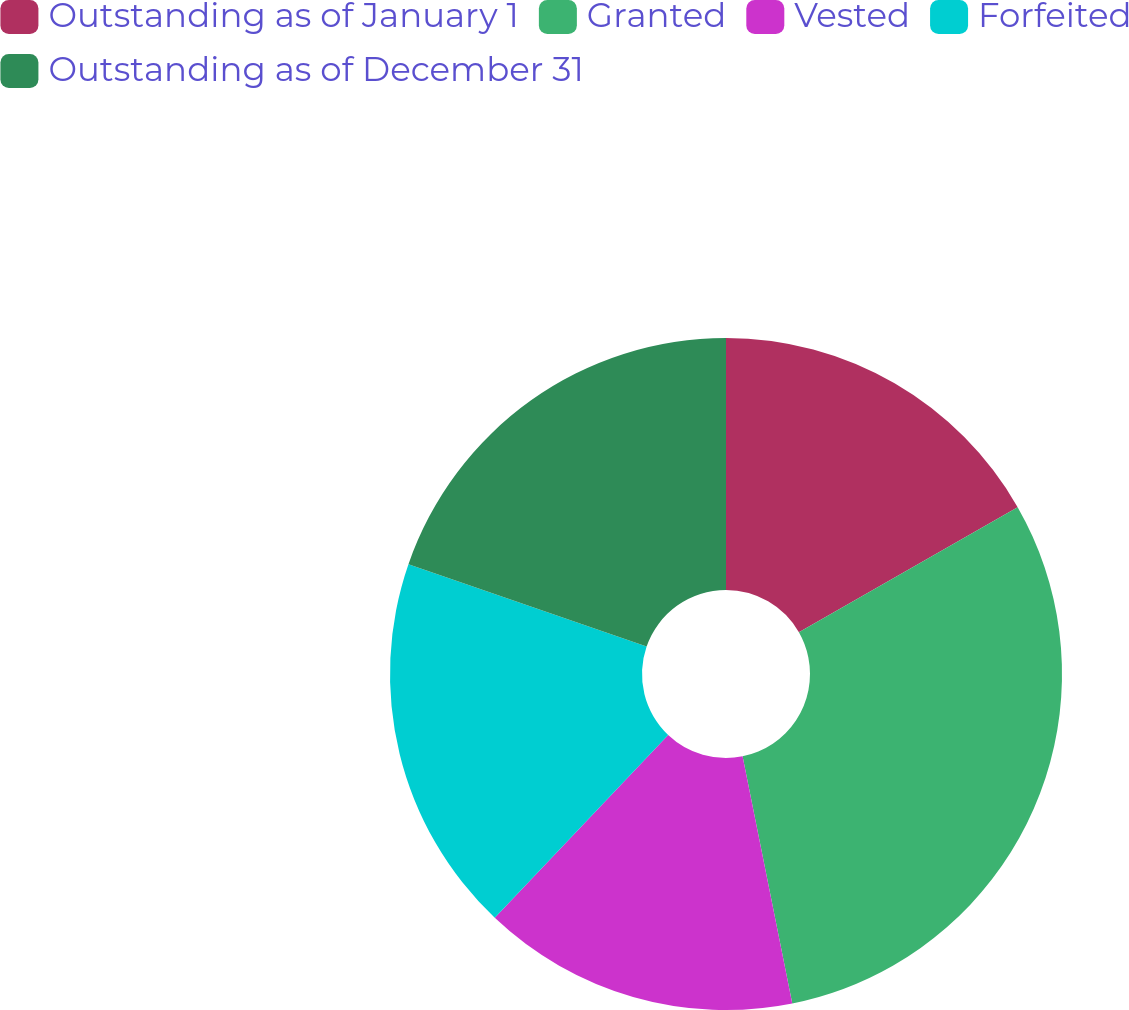Convert chart. <chart><loc_0><loc_0><loc_500><loc_500><pie_chart><fcel>Outstanding as of January 1<fcel>Granted<fcel>Vested<fcel>Forfeited<fcel>Outstanding as of December 31<nl><fcel>16.73%<fcel>30.11%<fcel>15.24%<fcel>18.22%<fcel>19.7%<nl></chart> 